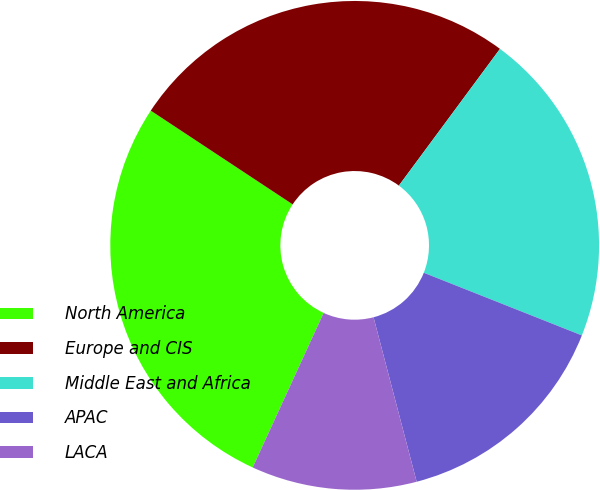<chart> <loc_0><loc_0><loc_500><loc_500><pie_chart><fcel>North America<fcel>Europe and CIS<fcel>Middle East and Africa<fcel>APAC<fcel>LACA<nl><fcel>27.44%<fcel>25.84%<fcel>20.87%<fcel>14.91%<fcel>10.93%<nl></chart> 